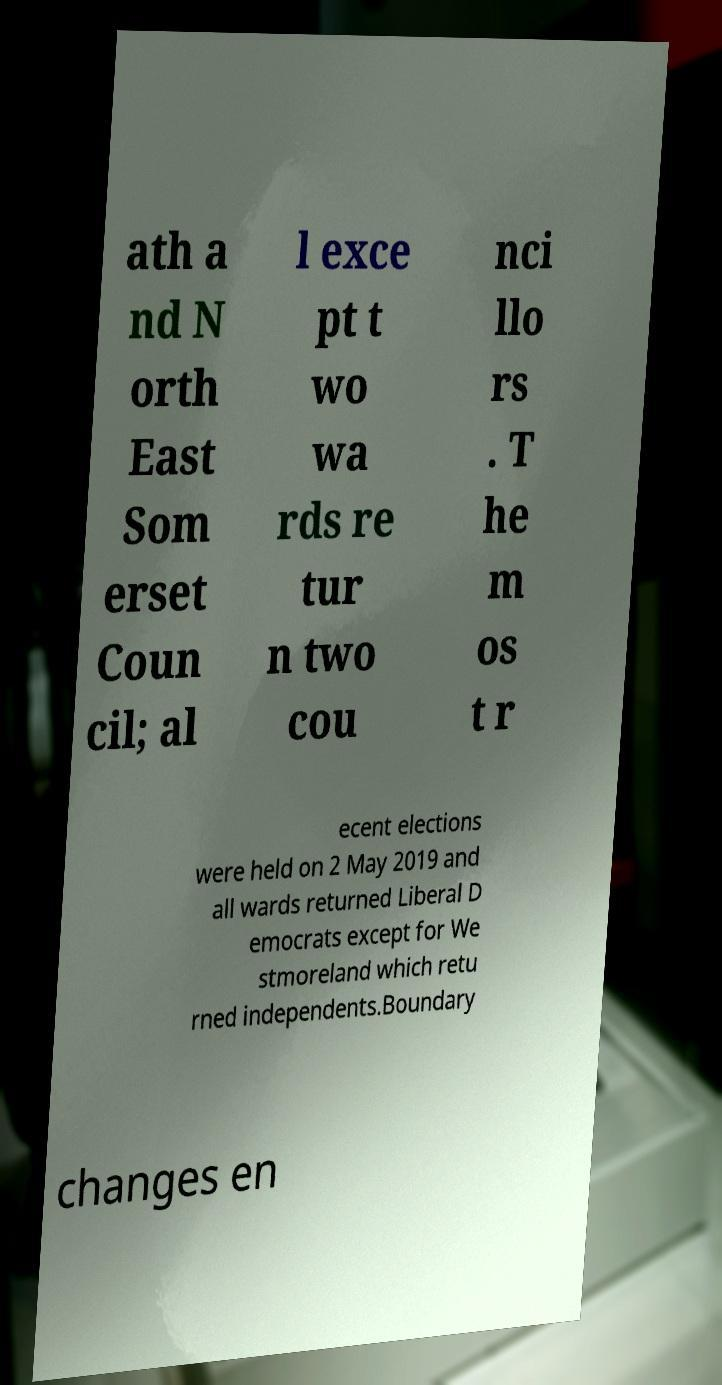Please read and relay the text visible in this image. What does it say? ath a nd N orth East Som erset Coun cil; al l exce pt t wo wa rds re tur n two cou nci llo rs . T he m os t r ecent elections were held on 2 May 2019 and all wards returned Liberal D emocrats except for We stmoreland which retu rned independents.Boundary changes en 